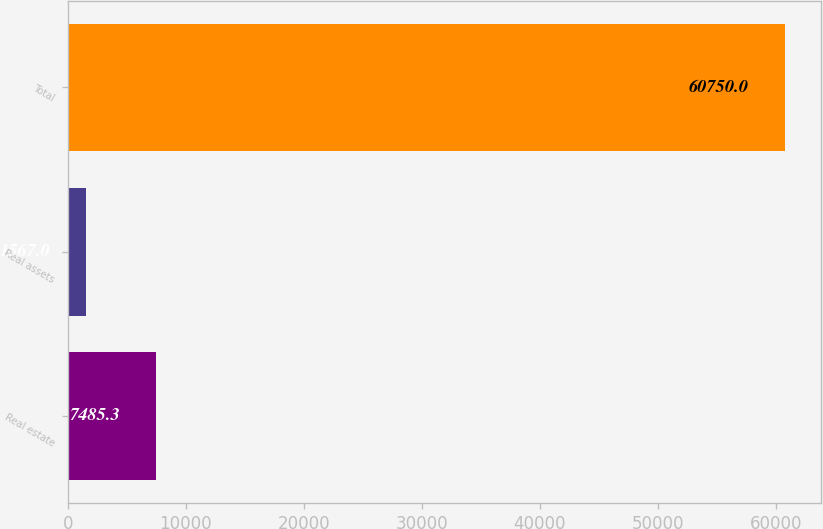<chart> <loc_0><loc_0><loc_500><loc_500><bar_chart><fcel>Real estate<fcel>Real assets<fcel>Total<nl><fcel>7485.3<fcel>1567<fcel>60750<nl></chart> 